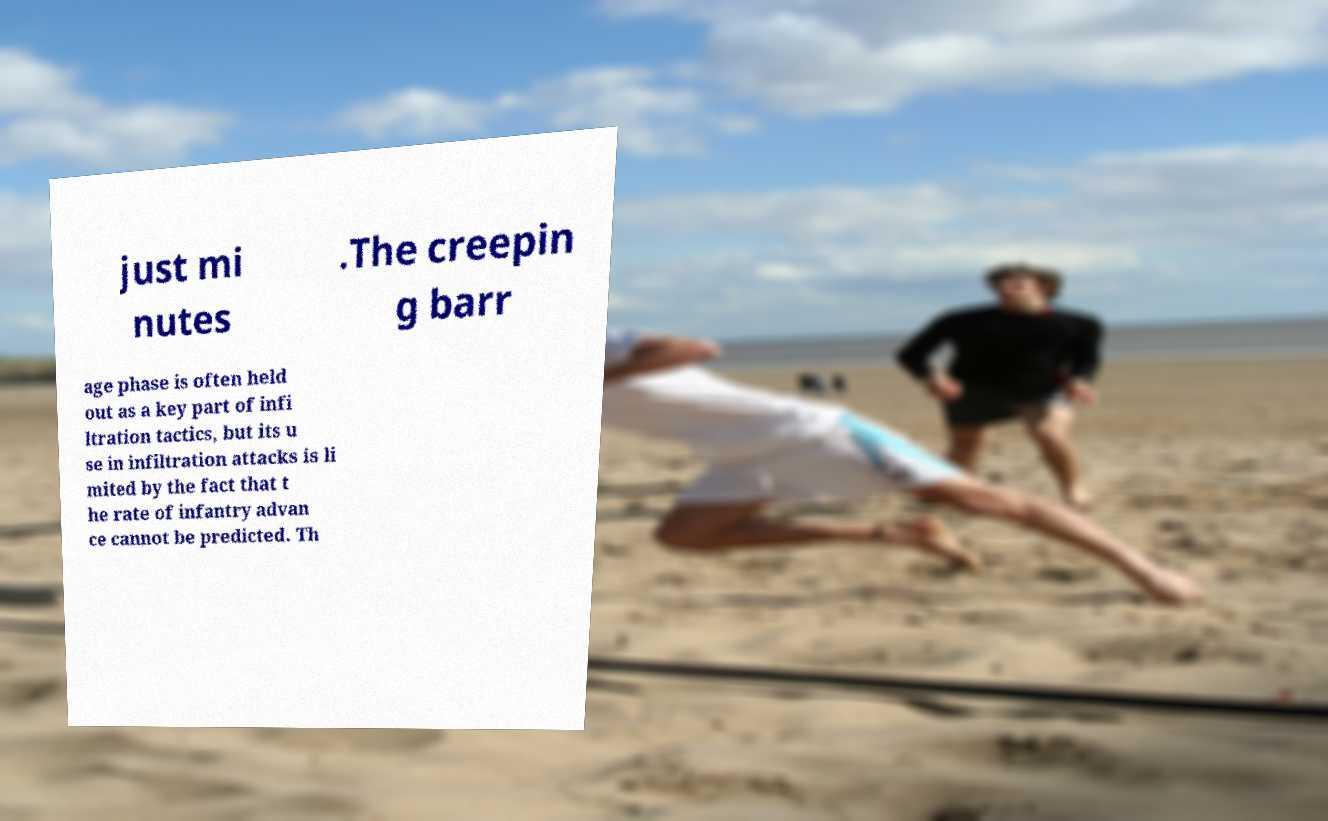For documentation purposes, I need the text within this image transcribed. Could you provide that? just mi nutes .The creepin g barr age phase is often held out as a key part of infi ltration tactics, but its u se in infiltration attacks is li mited by the fact that t he rate of infantry advan ce cannot be predicted. Th 